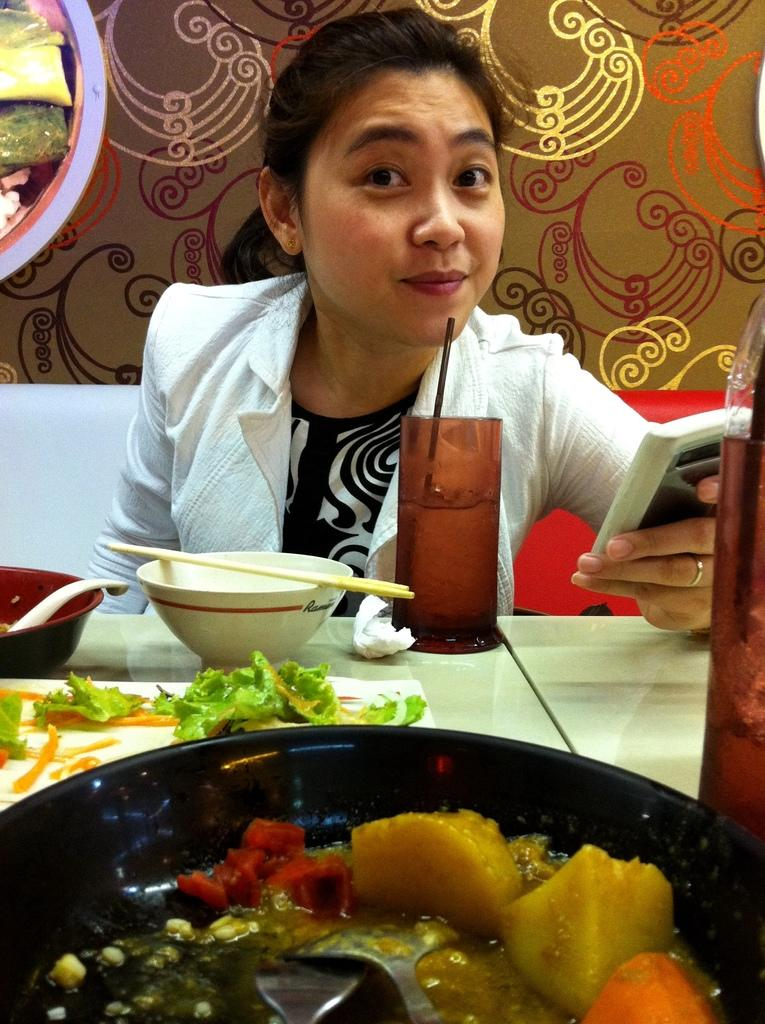What is the girl in the image doing? The girl is sitting in the image. What is the girl holding in her hand? The girl is holding a mobile phone in her hand. What is the girl wearing? The girl is wearing a white color sweater. What can be seen on the dining table in the image? There are food items on a dining table in the image. What type of coil is wrapped around the girl's leg in the image? There is no coil wrapped around the girl's leg in the image. What kind of brick is visible on the dining table in the image? There are no bricks visible on the dining table or anywhere else in the image. 